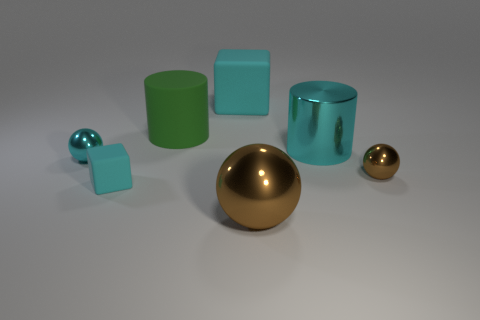Add 1 green rubber objects. How many objects exist? 8 Subtract all small brown spheres. How many spheres are left? 2 Subtract all yellow cylinders. How many blue spheres are left? 0 Subtract all big metal things. Subtract all metal blocks. How many objects are left? 5 Add 6 small cyan rubber blocks. How many small cyan rubber blocks are left? 7 Add 6 green cylinders. How many green cylinders exist? 7 Subtract all cyan spheres. How many spheres are left? 2 Subtract 0 green cubes. How many objects are left? 7 Subtract all cubes. How many objects are left? 5 Subtract 1 cylinders. How many cylinders are left? 1 